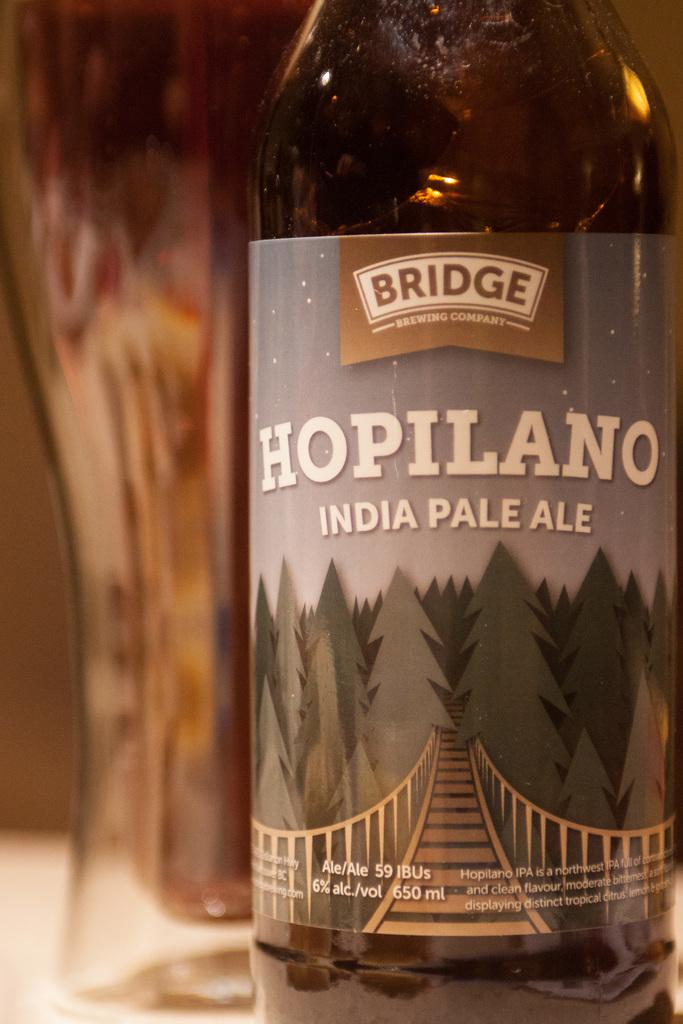<image>
Share a concise interpretation of the image provided. A bottle of Bridge brewing company Hopilano India Pale Ale on a table. 